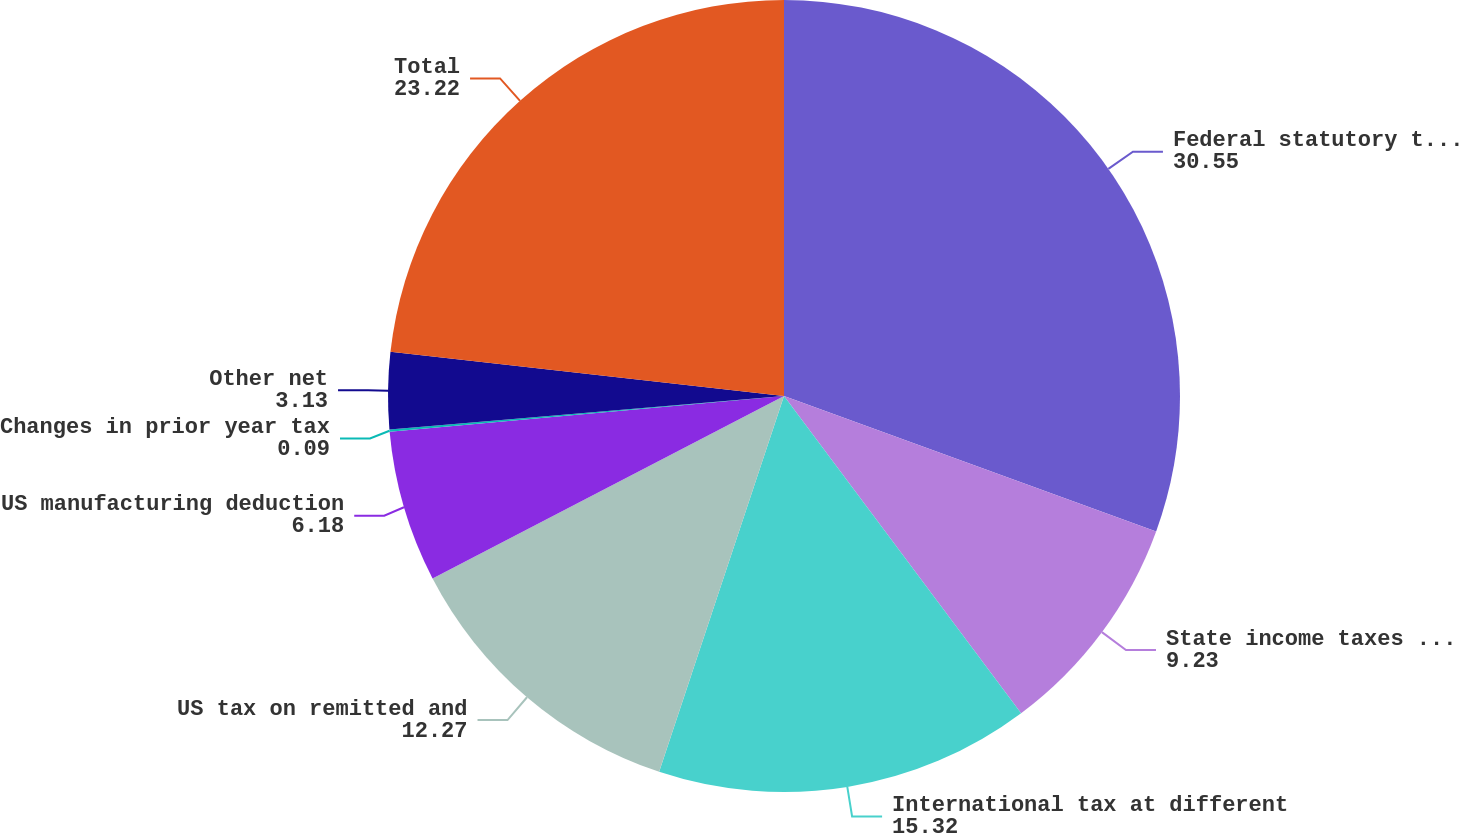Convert chart. <chart><loc_0><loc_0><loc_500><loc_500><pie_chart><fcel>Federal statutory tax rate<fcel>State income taxes net of<fcel>International tax at different<fcel>US tax on remitted and<fcel>US manufacturing deduction<fcel>Changes in prior year tax<fcel>Other net<fcel>Total<nl><fcel>30.55%<fcel>9.23%<fcel>15.32%<fcel>12.27%<fcel>6.18%<fcel>0.09%<fcel>3.13%<fcel>23.22%<nl></chart> 